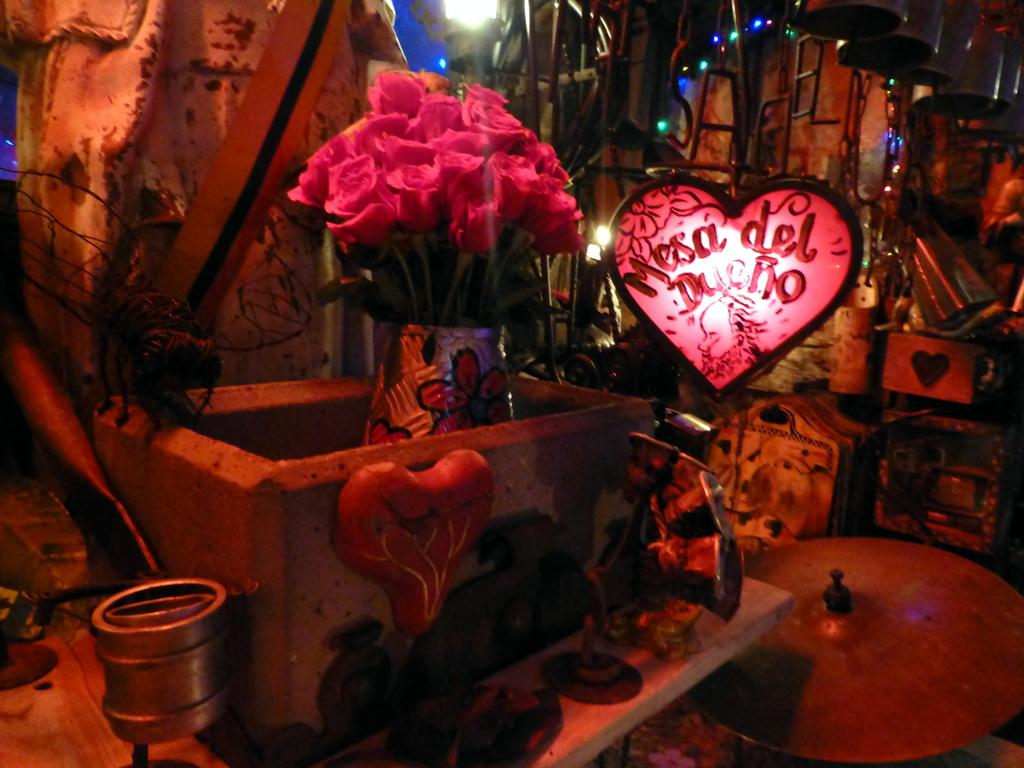What type of flowers are in the vase in the image? There are roses in a vase in the image. What is the shape of the stand in the image? There is a heart-shaped stand in the image. What can be seen illuminated in the image? There are lights visible in the image. What musical instrument is present in the image? There is a cymbal in the image. What other musical objects are present in the image? There are bells in the image. Can you describe any other objects in the image? There are other unspecified objects in the image. What type of school can be seen in the image? There is no school present in the image. How does the cymbal rub against the bells in the image? The cymbal and bells are separate objects in the image and do not interact with each other in that way. 